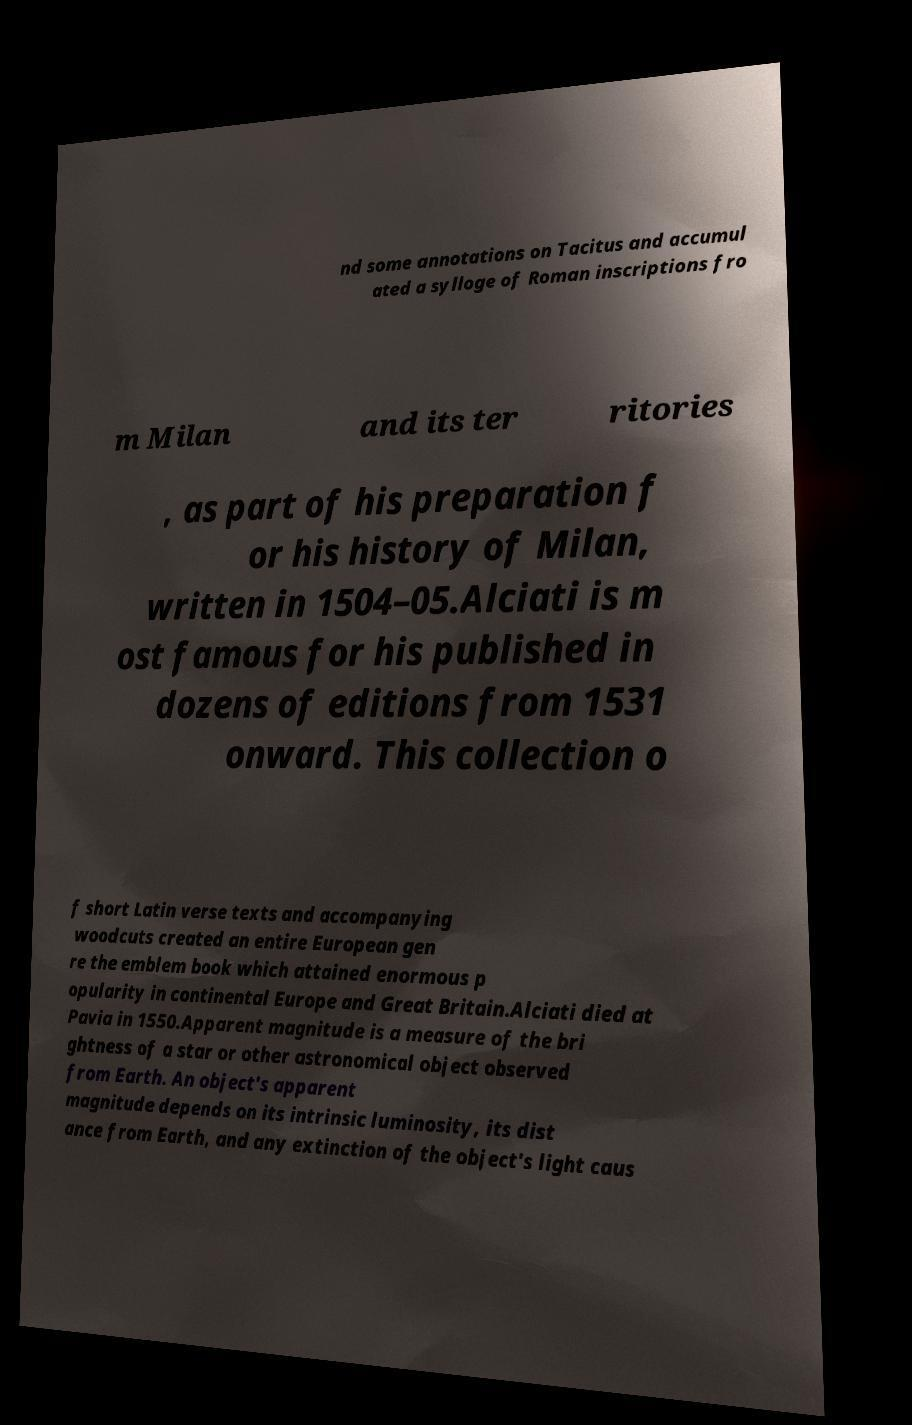Can you read and provide the text displayed in the image?This photo seems to have some interesting text. Can you extract and type it out for me? nd some annotations on Tacitus and accumul ated a sylloge of Roman inscriptions fro m Milan and its ter ritories , as part of his preparation f or his history of Milan, written in 1504–05.Alciati is m ost famous for his published in dozens of editions from 1531 onward. This collection o f short Latin verse texts and accompanying woodcuts created an entire European gen re the emblem book which attained enormous p opularity in continental Europe and Great Britain.Alciati died at Pavia in 1550.Apparent magnitude is a measure of the bri ghtness of a star or other astronomical object observed from Earth. An object's apparent magnitude depends on its intrinsic luminosity, its dist ance from Earth, and any extinction of the object's light caus 